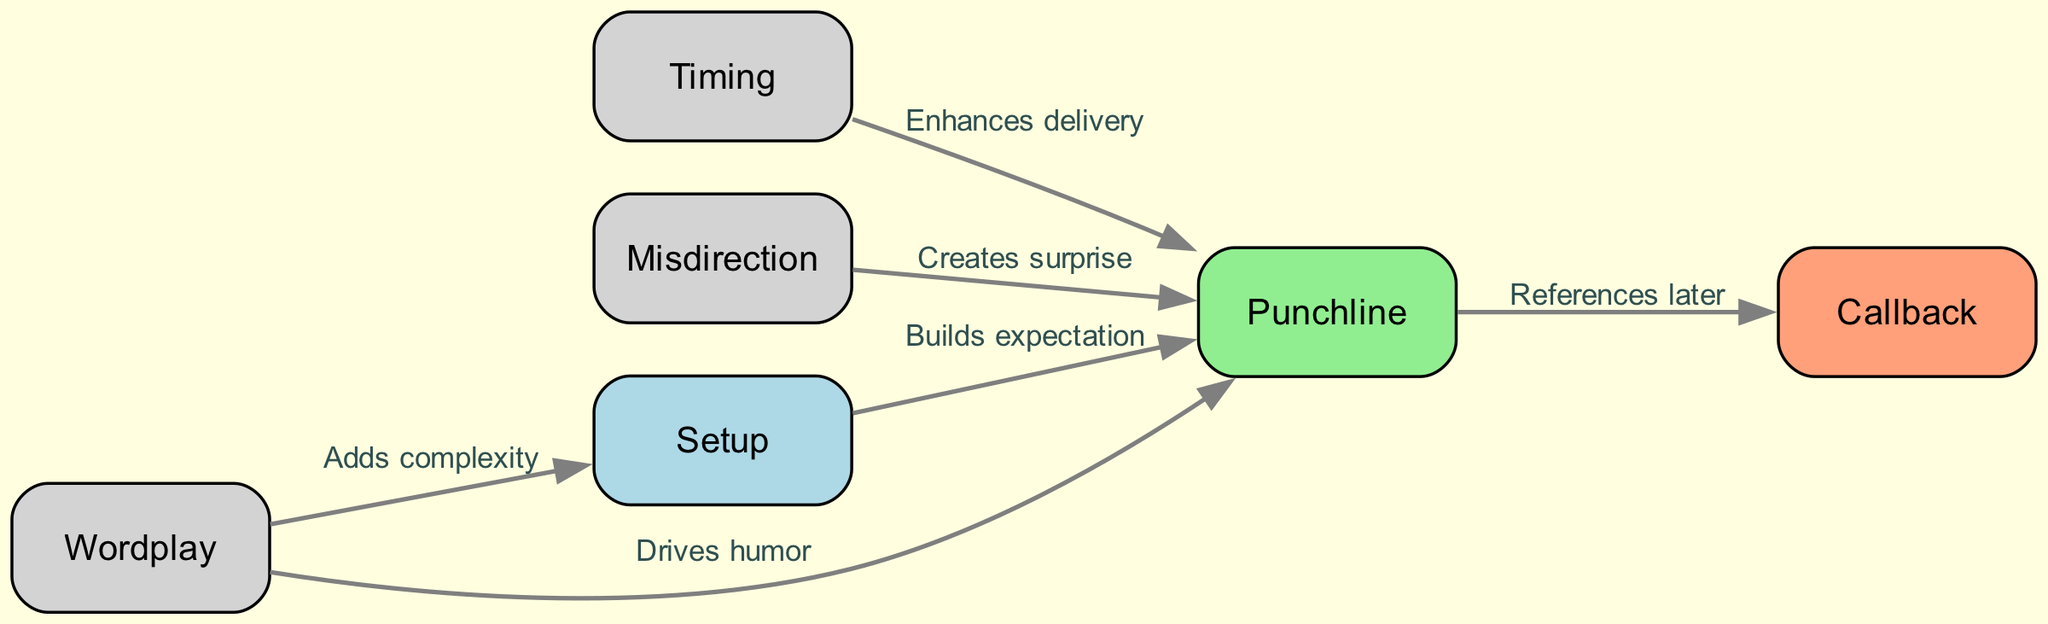What are the three main components of joke structure shown in the diagram? The nodes identified in the diagram are "Setup," "Punchline," and "Callback," which are explicitly labeled as key components of joke structure.
Answer: Setup, Punchline, Callback How many edges are connecting the nodes in the diagram? By counting the edges listed in the diagram data, we find that there are a total of five connections made between the nodes.
Answer: Five What does the edge from "Setup" to "Punchline" signify? The edge indicates that the "Setup" builds expectation for the "Punchline," which is directly stated on the edge label as "Builds expectation."
Answer: Builds expectation Which node does "Wordplay" connect to that adds complexity? The diagram indicates that "Wordplay" connects to the "Setup," and the edge label specifies that it "Adds complexity."
Answer: Setup What relationship does "Timing" have with the "Punchline"? "Timing" enhances the delivery of the "Punchline," as shown by the edge that connects these two nodes with the label "Enhances delivery."
Answer: Enhances delivery If "Misdirection" is utilized, which node does it connect to and what effect does it create? "Misdirection" connects to "Punchline," and according to the edge label, it creates a surprise when used.
Answer: Creates surprise How does the "Callback" relate to the "Punchline"? "Callback" references the "Punchline" later, which is what the edge labeled "References later" indicates in the diagram.
Answer: References later What aspect of humor is driven by the connection from "Wordplay" to "Punchline"? The connection shows that "Wordplay" drives humor to reach the "Punchline," as mentioned in the edge label "Drives humor."
Answer: Drives humor Which component of joke structure is enhanced by timing according to the diagram? The component that is enhanced is "Punchline," which is linked directly to timing through the labeled edge that reads "Enhances delivery."
Answer: Punchline 